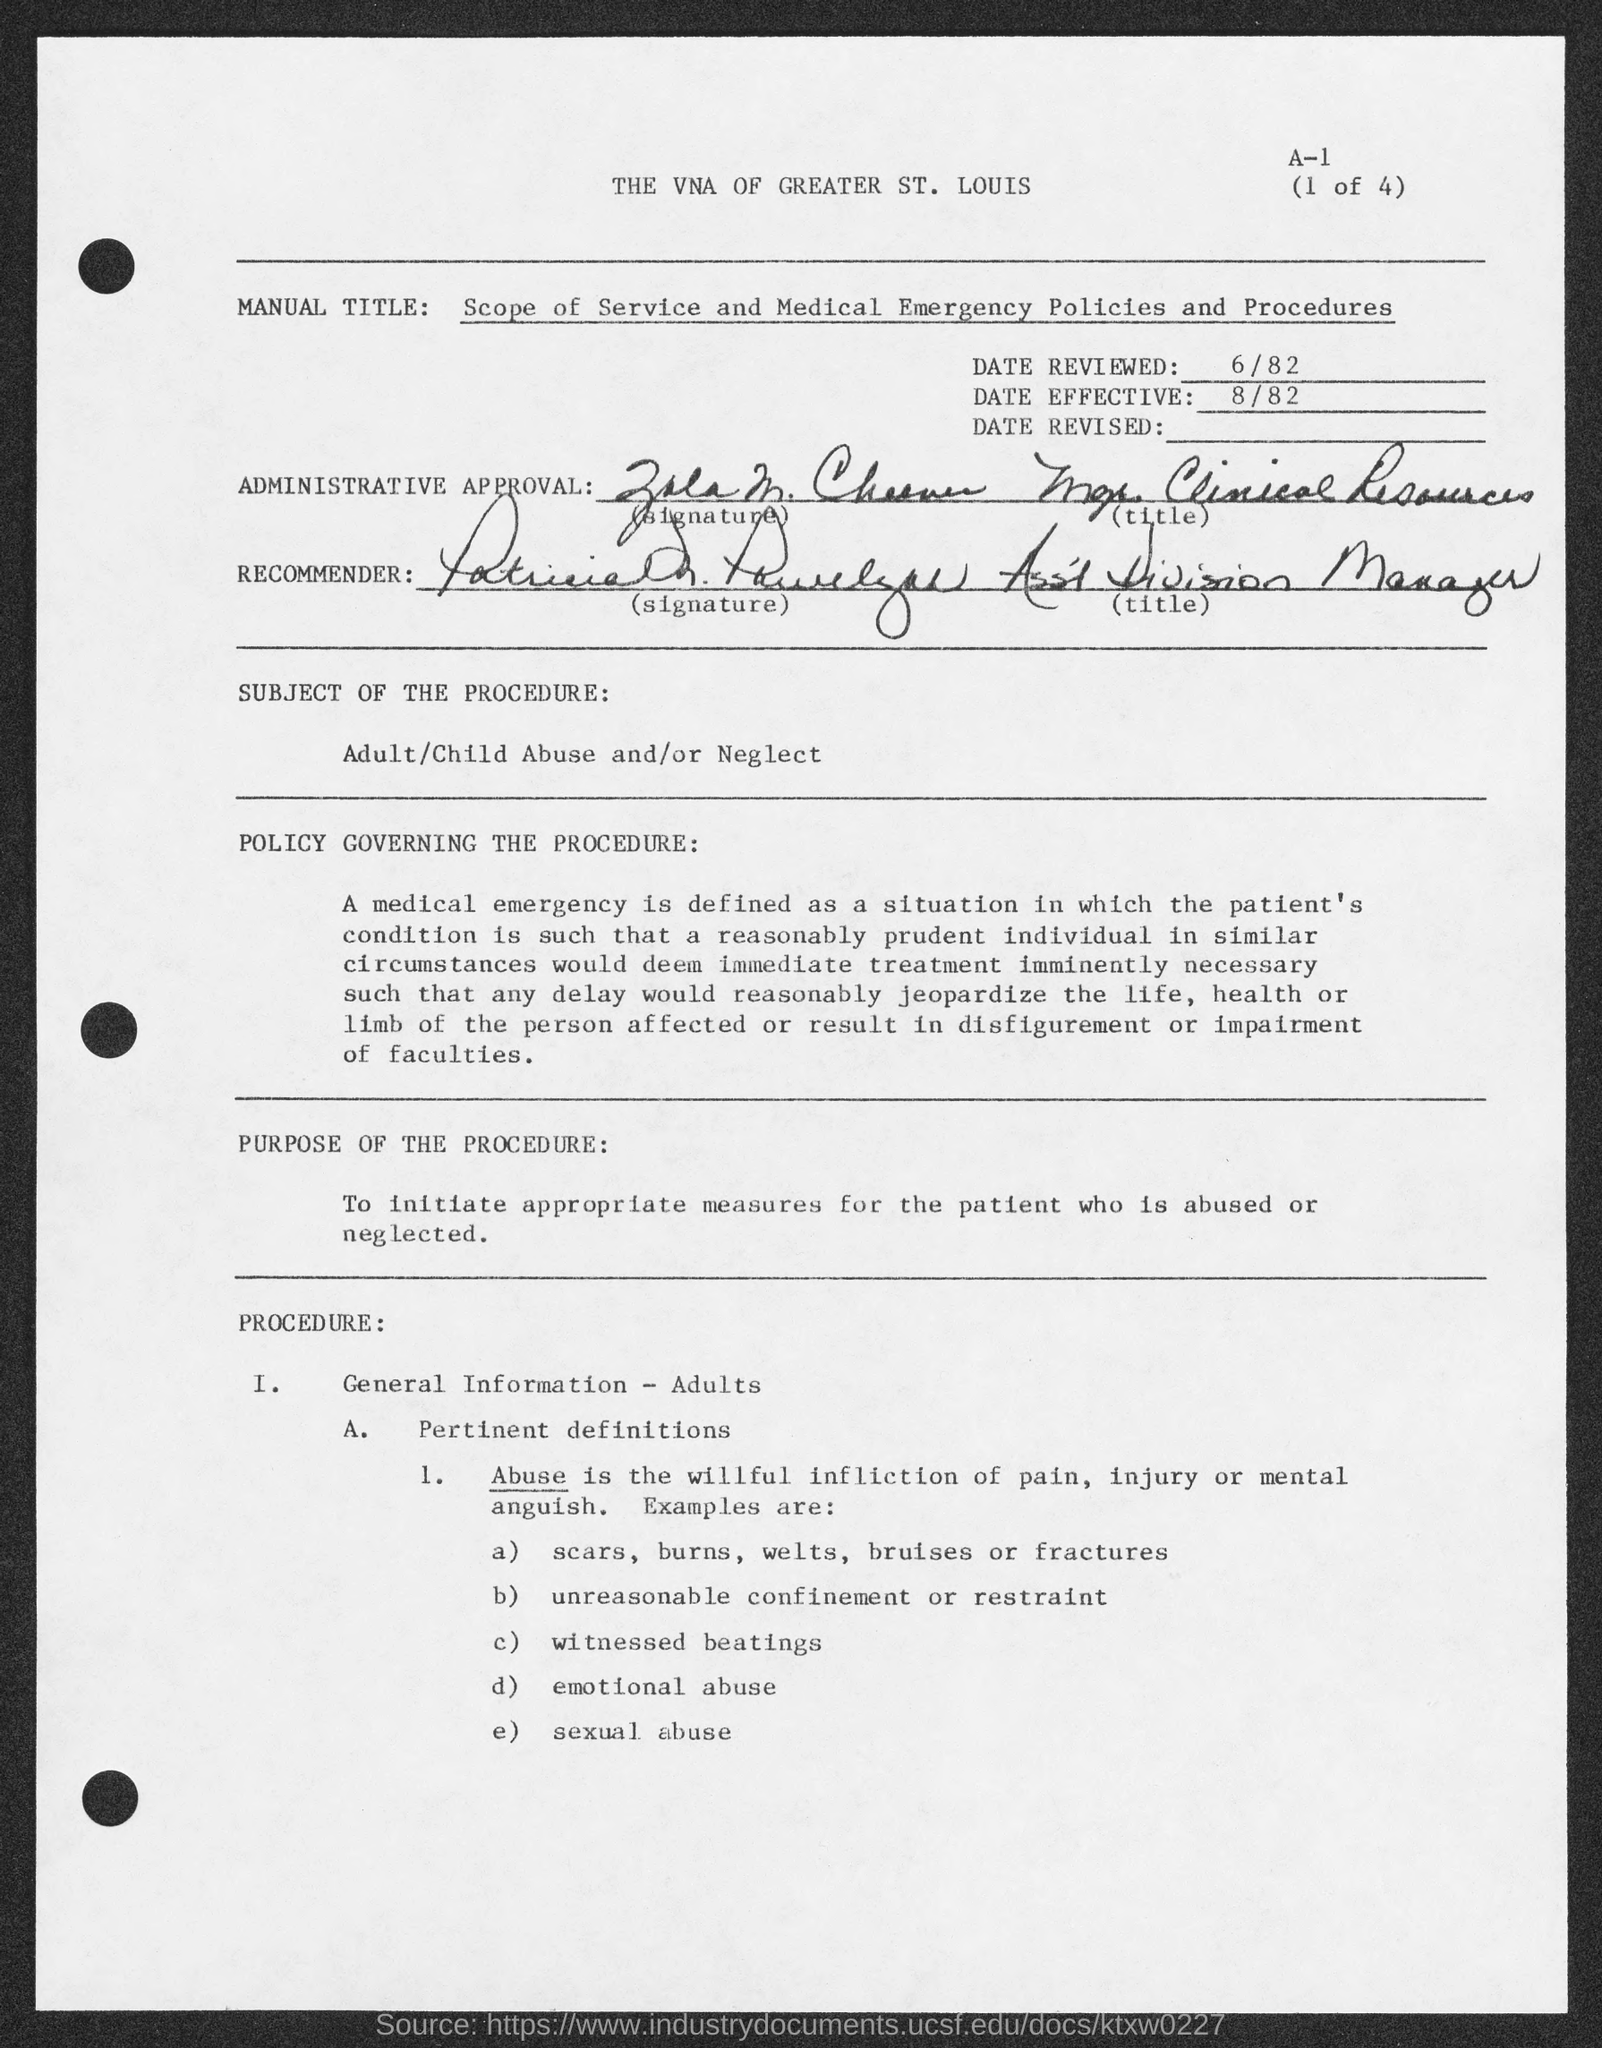What is the " Manual Title" ?
Provide a short and direct response. Scope of service and medical emergency policies and procedures. What is the "Date Reviewed" ?
Your answer should be compact. 6/82. What is the " Date Effective" ?
Offer a terse response. 8/82. What is the "Subject of the procedure" ?
Offer a very short reply. Adult/Child Abuse and/or Neglect. To whom,the general information was provided in the procedure?
Provide a short and direct response. Adults. What is the "Purpose of the procedure"?
Make the answer very short. To initiate appropriate measures for the patient who is abused or neglected. 